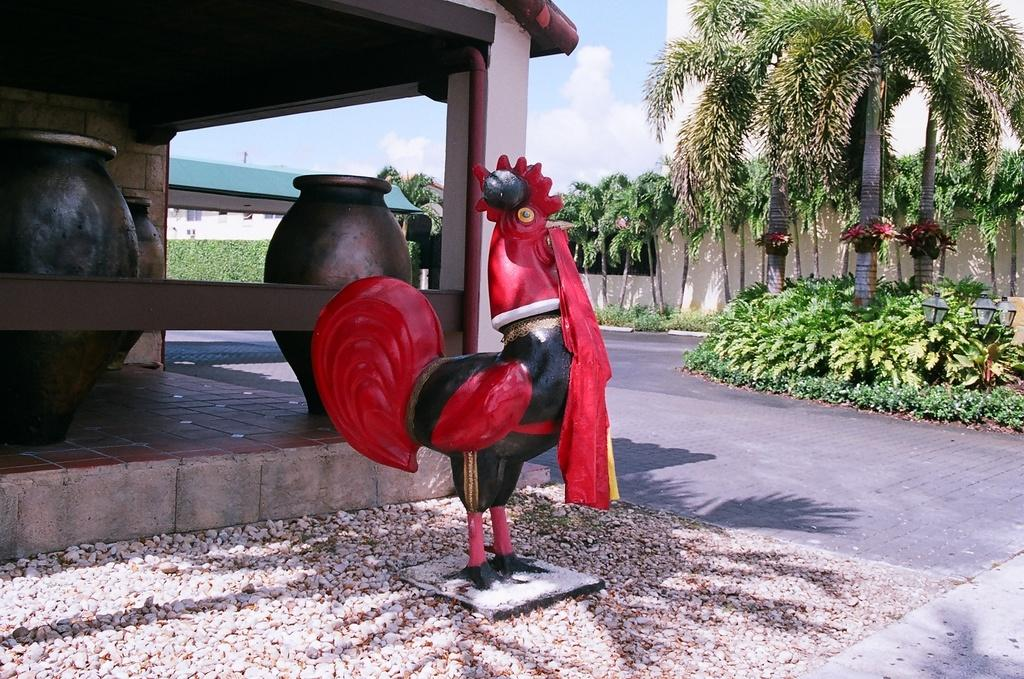What is the main subject of the image? There is a statue of a hen in the image. What colors are used for the statue? The statue is in red and black color. What can be seen in the background of the image? There are trees and buildings in the background of the image. What type of substance is being used to quiet the hen's crow in the image? There is no indication in the image that the hen is crowing or that any substance is being used to quiet it. 